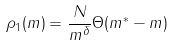Convert formula to latex. <formula><loc_0><loc_0><loc_500><loc_500>\rho _ { 1 } ( m ) = { \frac { N } { m ^ { \delta } } } \Theta ( m ^ { * } - m )</formula> 